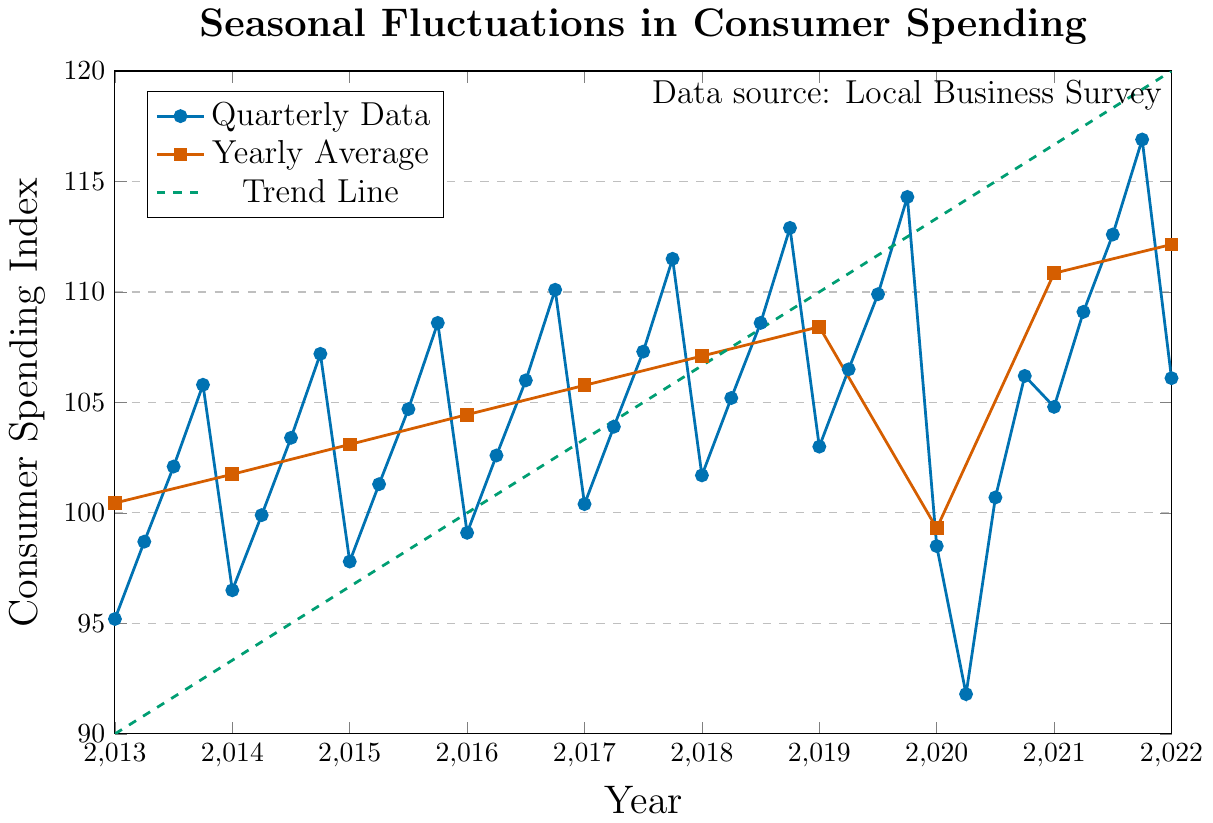what is the overall trend in consumer spending index over the decade? The trend line in green shows a steady increase from 90 in 2013 to 120 in 2022, indicating an overall upward trend in consumer spending over the decade.
Answer: Upward trend During which quarter did the consumer spending index reach its lowest point? The lowest point in the consumer spending index is in Q2 of 2020, where the index value drops to 91.8.
Answer: Q2 2020 How does the yearly average consumer spending index in 2020 compare to the yearly average in 2021? The yearly average consumer spending index in 2020 is 99.3, whereas in 2021 it is significantly higher at 110.85.
Answer: 2021 is higher What is the difference between the consumer spending index in Q4 2019 and Q4 2021? The consumer spending index in Q4 2019 is 114.3, and in Q4 2021 it is 116.9. The difference is 116.9 - 114.3 = 2.6.
Answer: 2.6 Which quarter shows the highest increase in consumer spending index from the previous quarter? Q3 2020 to Q4 2020 shows the highest increase, as the index jumps from 100.7 to 106.2, an increment of 5.5.
Answer: Q4 2020 Is there any yearly average consumer spending index that decreased from the previous year? Yes, the yearly average consumer spending index decreased from 108.425 in 2019 to 99.3 in 2020.
Answer: 2020 Which year shows the highest average consumer spending? The year 2022 shows the highest average consumer spending with an index of 112.15.
Answer: 2022 By how much did the consumer spending index increase from Q1 2021 to Q1 2022? The consumer spending index increased from 104.8 in Q1 2021 to 106.1 in Q1 2022. The increase is 106.1 - 104.8 = 1.3.
Answer: 1.3 Looking at the trend line, if the trend continues, what is the projected consumer spending index for the year 2023? The trend line increases by an average of 3.33 points per year. If this trend continues, the projected index for 2023 would be 120 + 3.33 = 123.33.
Answer: 123.33 